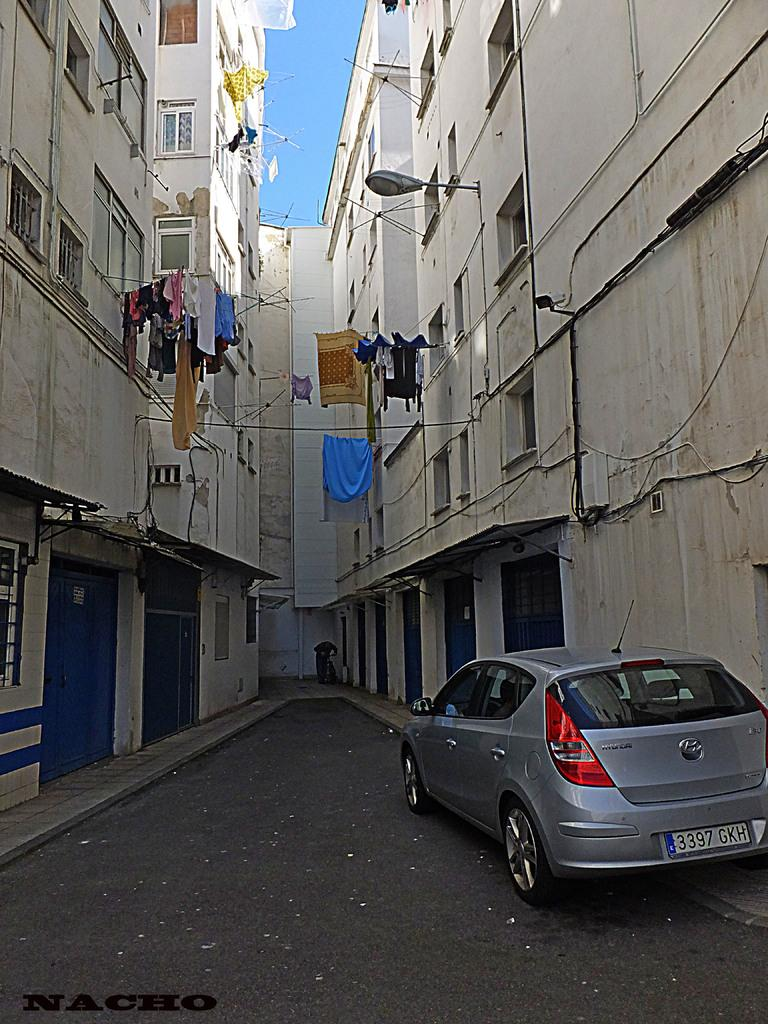What is the main subject of the image? There is a car in the image. What can be seen on either side of the car? There are buildings on either side of the car. What feature do the buildings have? The buildings have windows. What is hanging in the middle of the image? Clothes are hanging on a rope in the middle of the image. What is visible above the car and buildings? The sky is visible above the car and buildings. What type of horse can be seen participating in the activity in the image? There is no horse or activity present in the image; it features a car, buildings, clothes hanging on a rope, and the sky. 